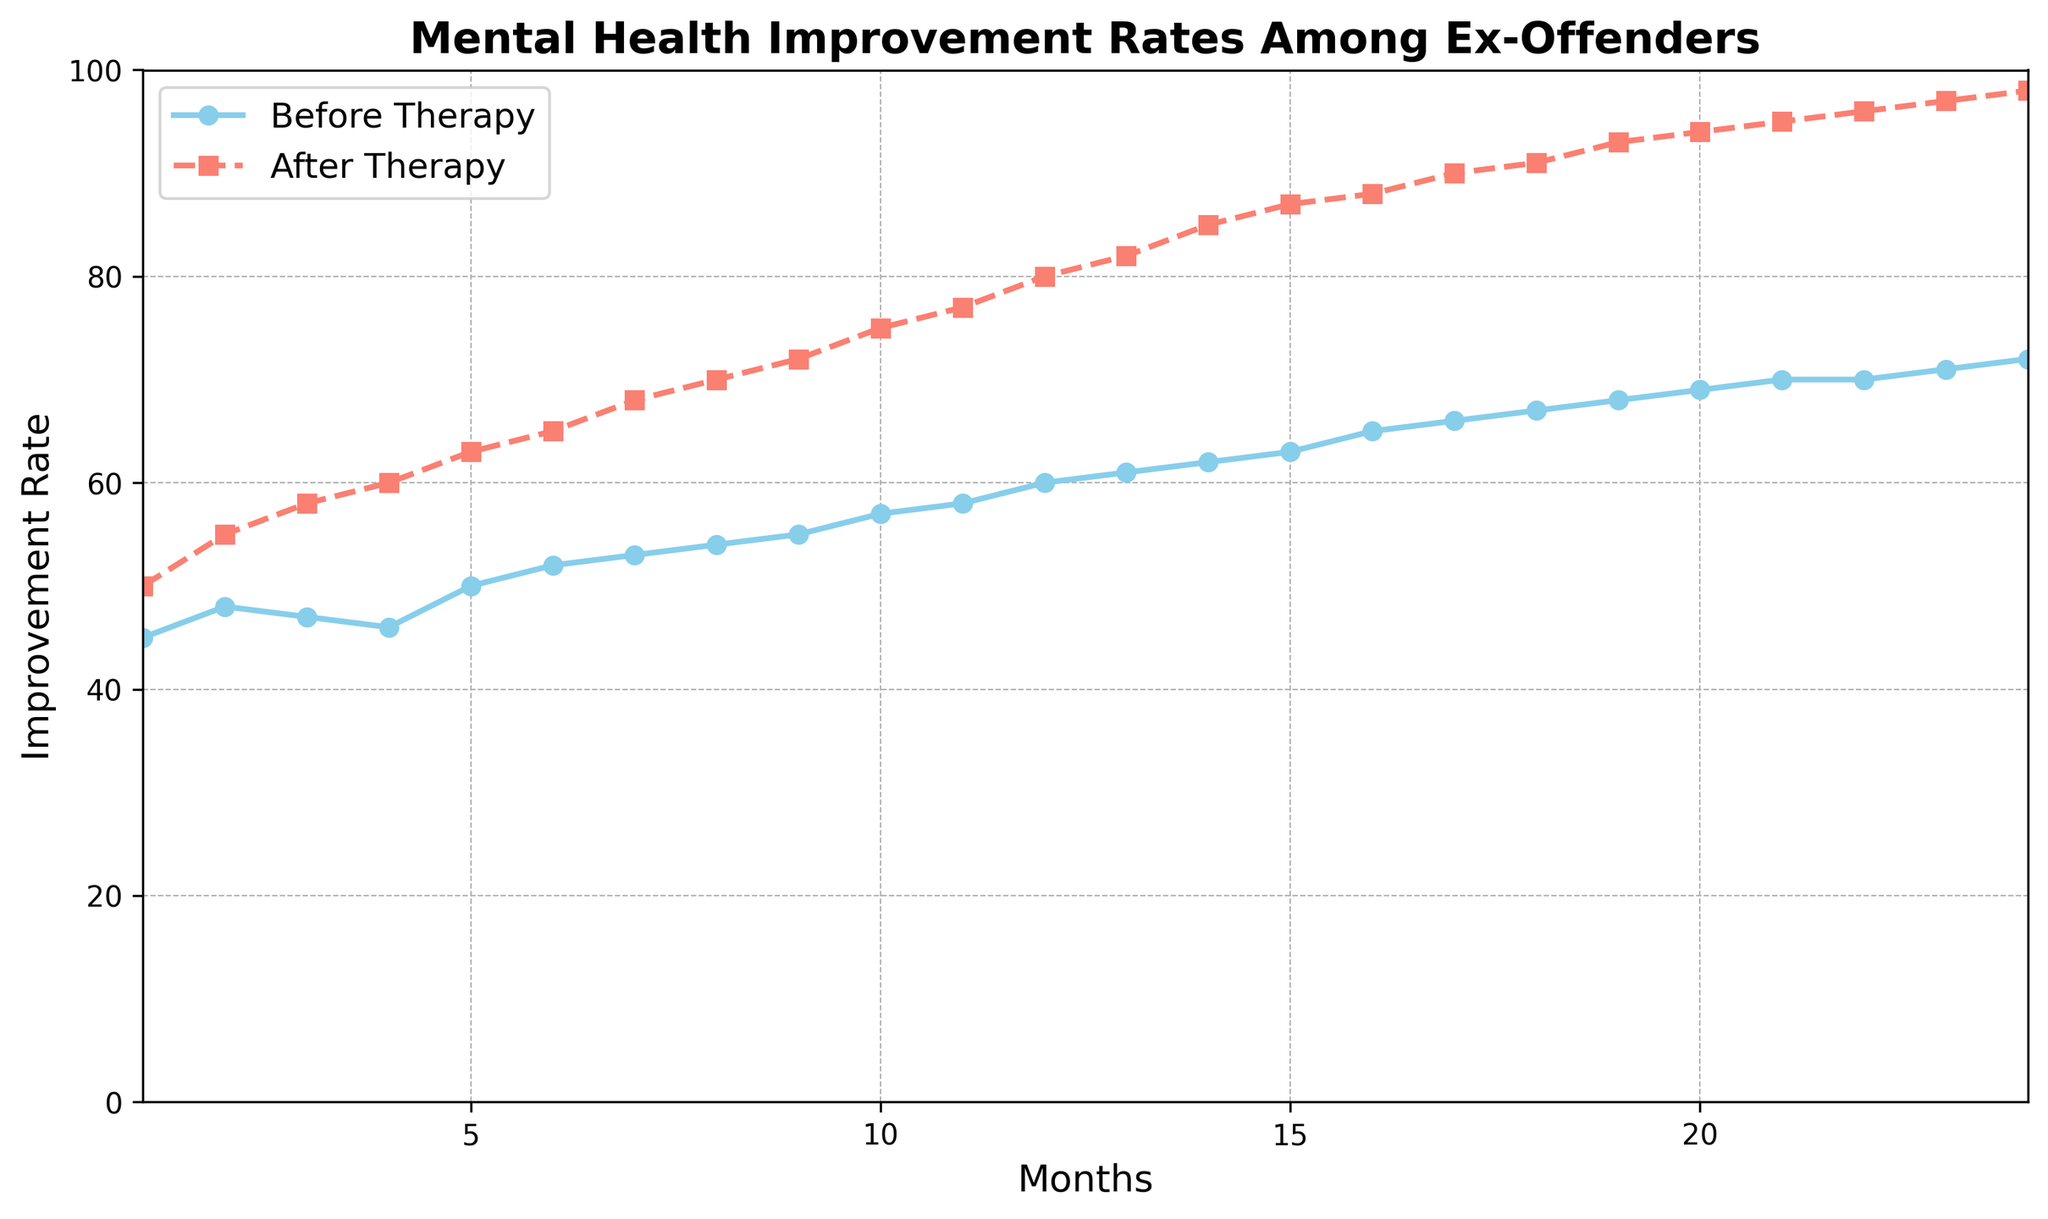What's the difference in mental health improvement rates between Before Therapy and After Therapy in Month 5? To find the difference, look at the improvement rates for Month 5 for both Before Therapy (50) and After Therapy (63). Subtract the Before Therapy rate from the After Therapy rate: 63 - 50 = 13.
Answer: 13 In which month do the After Therapy improvement rates first exceed 70? To identify the month when After Therapy improvement rates first exceed 70, scan the After Therapy line. It first happens in Month 9 (72).
Answer: Month 9 What is the average mental health improvement rate for After Therapy over the 24-month period? Add all After Therapy improvement rates (50 + 55 + 58 + 60 + 63 + 65 + 68 + 70 + 72 + 75 + 77 + 80 + 82 + 85 + 87 + 88 + 90 + 91 + 93 + 94 + 95 + 96 + 97 + 98), which sums to 1655, then divide by the number of months (24): 1655 / 24 ≈ 68.96.
Answer: 68.96 How much does the mental health improvement rate increase from Month 1 to Month 24 for Before Therapy? The Before Therapy improvement rate in Month 1 is 45, and in Month 24, it's 72. The increase is calculated as 72 - 45 = 27.
Answer: 27 Which line shows a steeper upward trend, Before Therapy or After Therapy? By comparing the overall trends of both lines, the After Therapy line exhibits a steeper upward slope, indicating a more significant increase over time compared to the Before Therapy line.
Answer: After Therapy What is the increase in mental health improvement rate for After Therapy from Month 12 to Month 18? After Therapy improvement rate in Month 12 is 80, and in Month 18, it's 91. The increase is calculated as 91 - 80 = 11.
Answer: 11 During which months are the improvement rates for Before Therapy constant at 70? By examining the Before Therapy line, the improvement rates are constant at 70 during Months 21 and 22.
Answer: Months 21 and 22 By how much do the mental health improvement rates differ between Before Therapy and After Therapy in Month 12? In Month 12, the Before Therapy rate is 60, and the After Therapy rate is 80. The difference is 80 - 60 = 20.
Answer: 20 What's the average monthly increase in improvement rate for After Therapy from Month 1 to Month 24? Differences between consecutive months for After Therapy are 5, 3, 2, 3, 2, 3, 2, 2, 3, 2, 3, 2, 3, 2, 1, 2, 1, 2, 1, 1, 1, 1, 1. Sum these differences is 48. Average is 48/23 ≈ 2.09.
Answer: 2.09 Which line has a more gradual increase in the months from 16 to 24? Observing the segments from months 16 to 24 for both lines, the After Therapy line demonstrates a more gradual increase than the Before Therapy line.
Answer: Before Therapy 